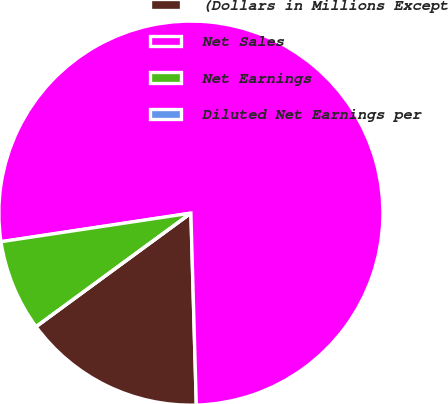Convert chart. <chart><loc_0><loc_0><loc_500><loc_500><pie_chart><fcel>(Dollars in Millions Except<fcel>Net Sales<fcel>Net Earnings<fcel>Diluted Net Earnings per<nl><fcel>15.38%<fcel>76.92%<fcel>7.69%<fcel>0.0%<nl></chart> 